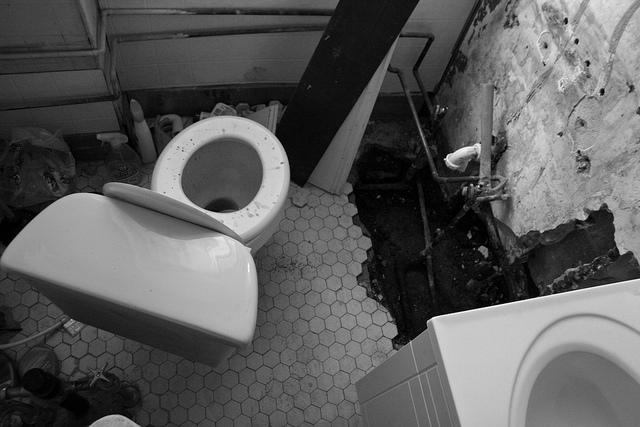What usually goes inside of the item with the lid?

Choices:
A) human waste
B) towels
C) cows
D) mcdonald's human waste 